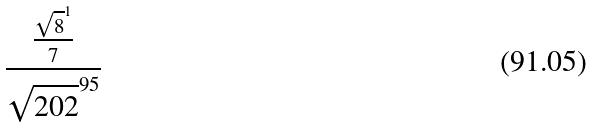<formula> <loc_0><loc_0><loc_500><loc_500>\frac { \frac { \sqrt { 8 } ^ { 1 } } { 7 } } { \sqrt { 2 0 2 } ^ { 9 5 } }</formula> 